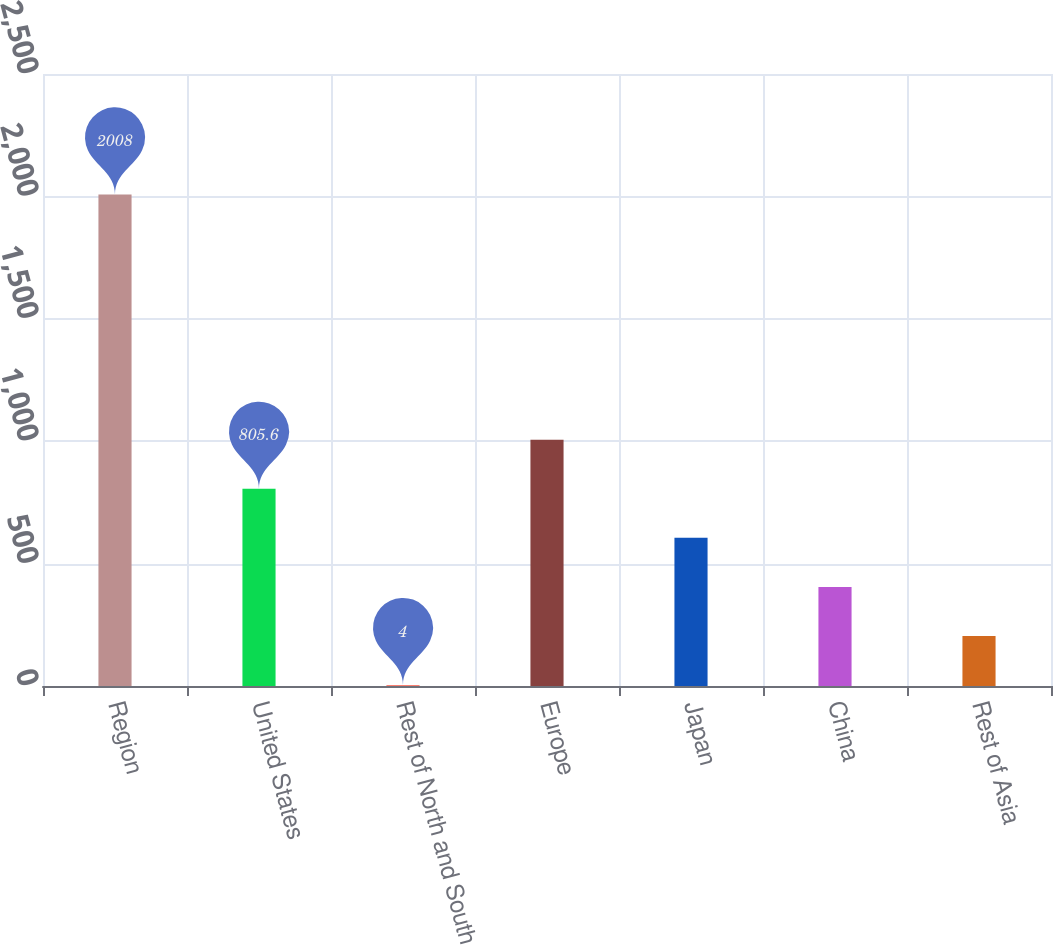Convert chart. <chart><loc_0><loc_0><loc_500><loc_500><bar_chart><fcel>Region<fcel>United States<fcel>Rest of North and South<fcel>Europe<fcel>Japan<fcel>China<fcel>Rest of Asia<nl><fcel>2008<fcel>805.6<fcel>4<fcel>1006<fcel>605.2<fcel>404.8<fcel>204.4<nl></chart> 